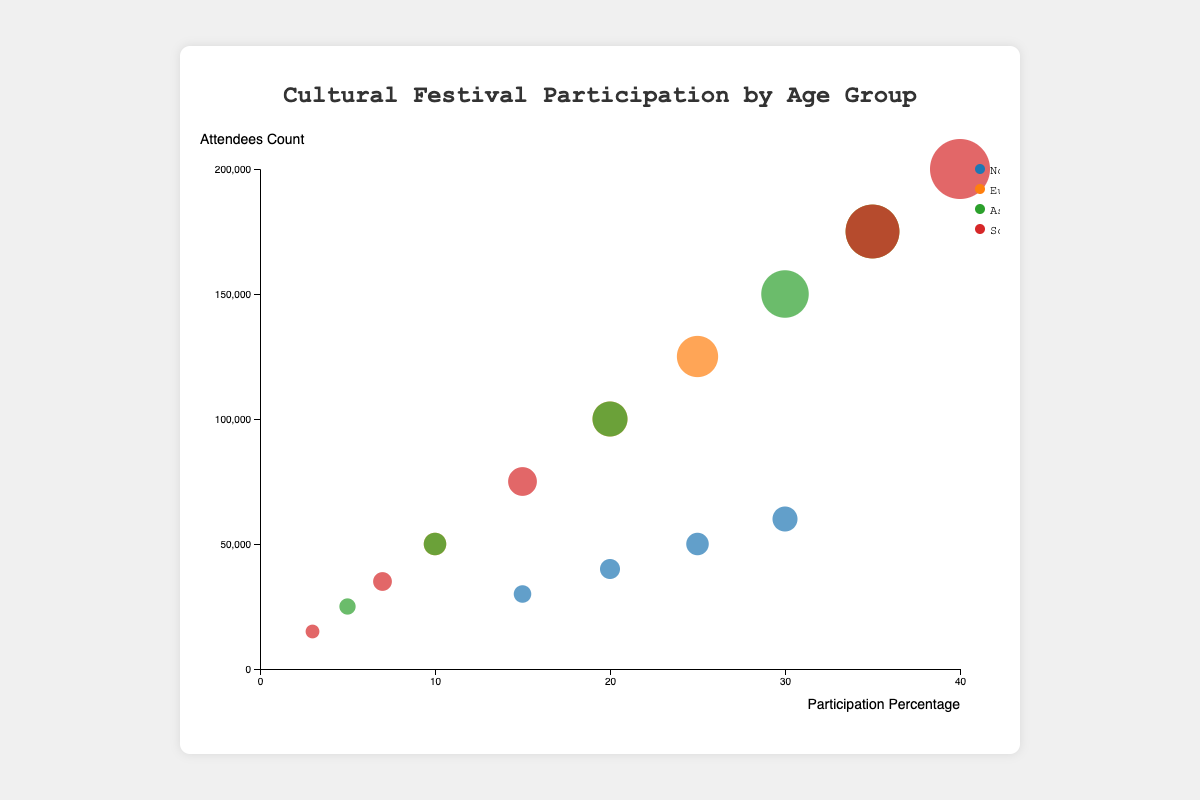What's the title of the bubble chart? The title of the chart is displayed prominently at the top of the figure and describes what the figure is about.
Answer: Cultural Festival Participation by Age Group What do the x and y axes represent? The x-axis represents the percentage of participation, while the y-axis represents the number of attendees. These labels are next to the respective axes.
Answer: Participation Percentage, Attendees Count Which region has the largest bubble representing the number of attendees? Identifying the largest bubble by comparing the sizes of all bubbles, paying attention to the largest circle at first glance.
Answer: Asia How many age groups are displayed for each festival? Inspect each festival's data points on the chart, noting that each unique color represents a different age group and adding update observation counts.
Answer: 4 to 5 age groups Which festival in North America has the highest participation percentage? Identify bubbles within the North America region, locate the bubble position farthest to the right (highest on x-axis), indicating the highest participation percentage.
Answer: Mardi Gras Between the 35-44 and 45-54 age groups for the Oktoberfest in Europe, which has higher participation? Observe the position of bubbles pertaining to these age groups under Europe. 35-44 age group has a higher participation percentage because it is plotted farther to the right.
Answer: 35-44 What is the total number of attendees for Diwali across all age groups? Sum the attendees count for all data points related to Diwali. The individual counts are 150,000 + 175,000 + 100,000 + 50,000 + 25,000.
Answer: 500,000 Which age group has the highest participation in Carnival in South America? Identify the highest bubble on the participation percentage axis within groups for Carnival in South America.
Answer: 18-24 Compare the participation percentage of 25-34 age group for Mardi Gras and Diwali. Which is higher? Review the bubbles representing 25-34 for Mardi Gras and Diwali. The 25-34 age group for Mardi Gras is 30%, while Diwali is 35%.
Answer: Diwali Does the 18-24 age group show the highest attendees count in every region? Inspect and compare all 18-24 age group bubbles across different regions, noting their attendees count on the y-axis. Asia (150,000) and South America (200,000) show higher counts compared to other regions.
Answer: No 